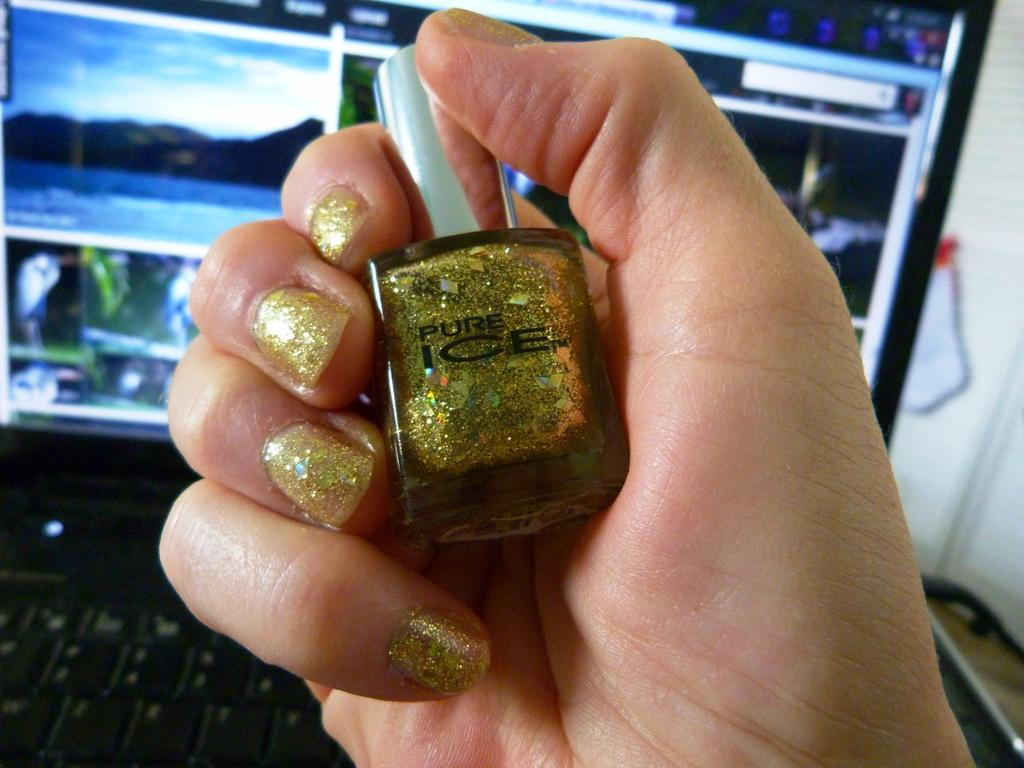<image>
Write a terse but informative summary of the picture. An yellow gold nail polish bottle held in right hand which says PURE ICE. 